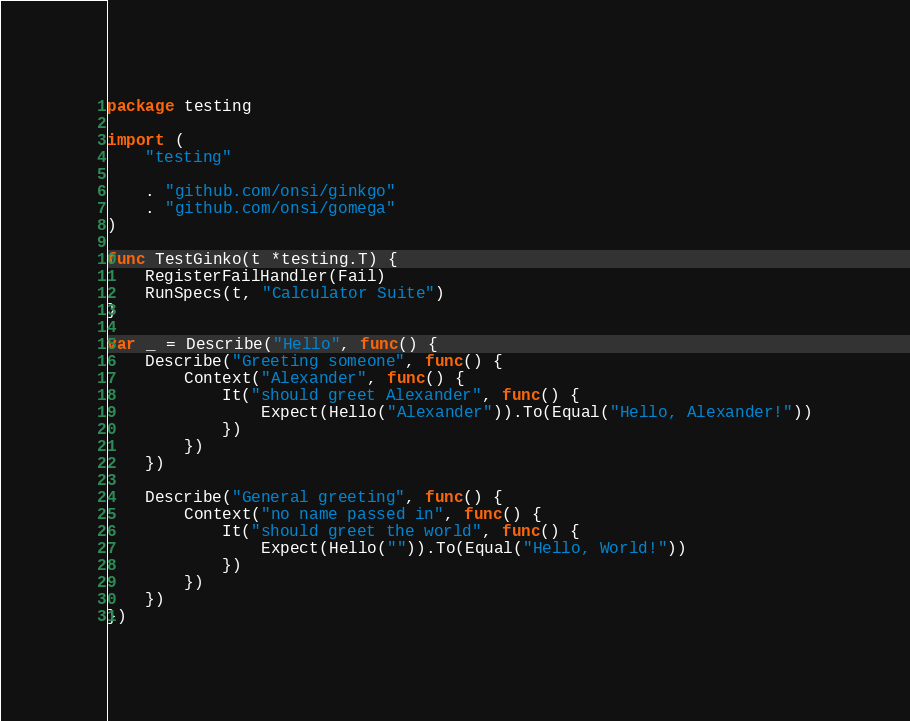Convert code to text. <code><loc_0><loc_0><loc_500><loc_500><_Go_>package testing

import (
	"testing"

	. "github.com/onsi/ginkgo"
	. "github.com/onsi/gomega"
)

func TestGinko(t *testing.T) {
	RegisterFailHandler(Fail)
	RunSpecs(t, "Calculator Suite")
}

var _ = Describe("Hello", func() {
	Describe("Greeting someone", func() {
		Context("Alexander", func() {
			It("should greet Alexander", func() {
				Expect(Hello("Alexander")).To(Equal("Hello, Alexander!"))
			})
		})
	})

	Describe("General greeting", func() {
		Context("no name passed in", func() {
			It("should greet the world", func() {
				Expect(Hello("")).To(Equal("Hello, World!"))
			})
		})
	})
})
</code> 